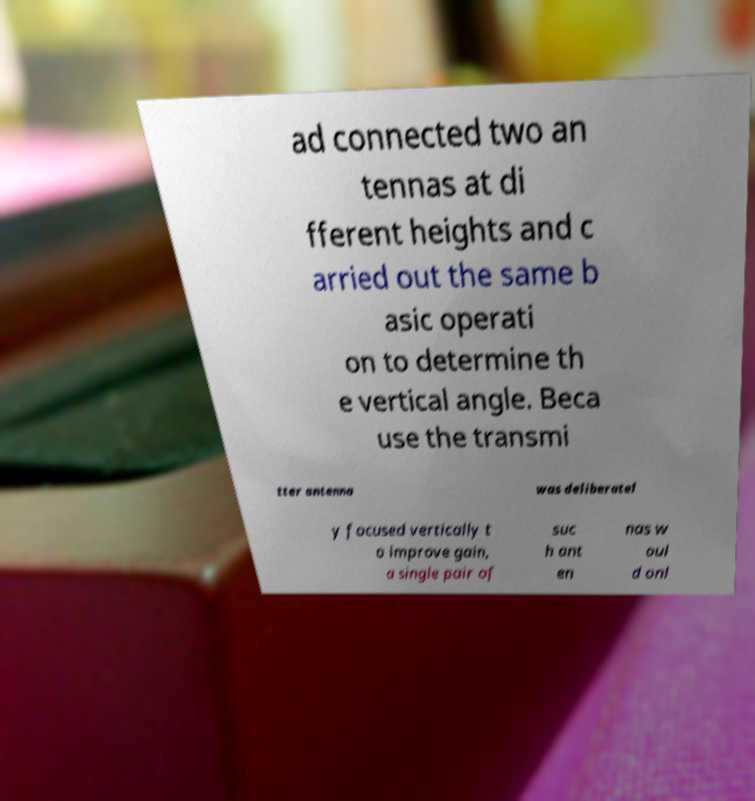Can you read and provide the text displayed in the image?This photo seems to have some interesting text. Can you extract and type it out for me? ad connected two an tennas at di fferent heights and c arried out the same b asic operati on to determine th e vertical angle. Beca use the transmi tter antenna was deliberatel y focused vertically t o improve gain, a single pair of suc h ant en nas w oul d onl 